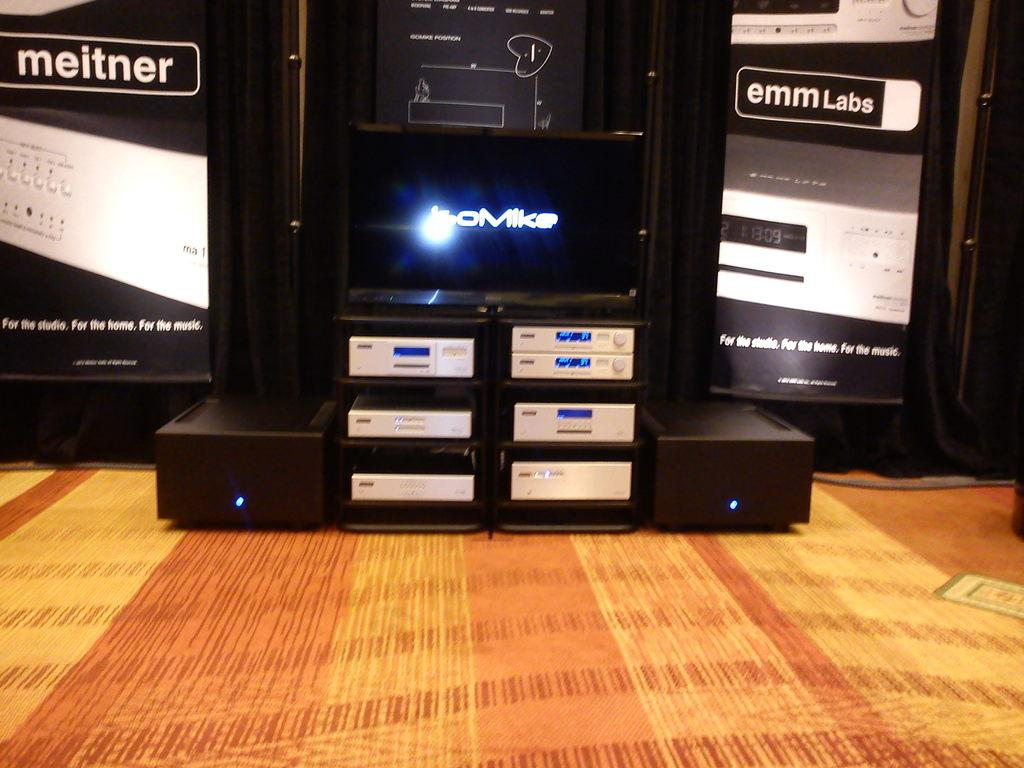<image>
Share a concise interpretation of the image provided. Electronics in a stand under a screen displaying 'oMike' between banners for 'meitner' and 'emm Labs'. 